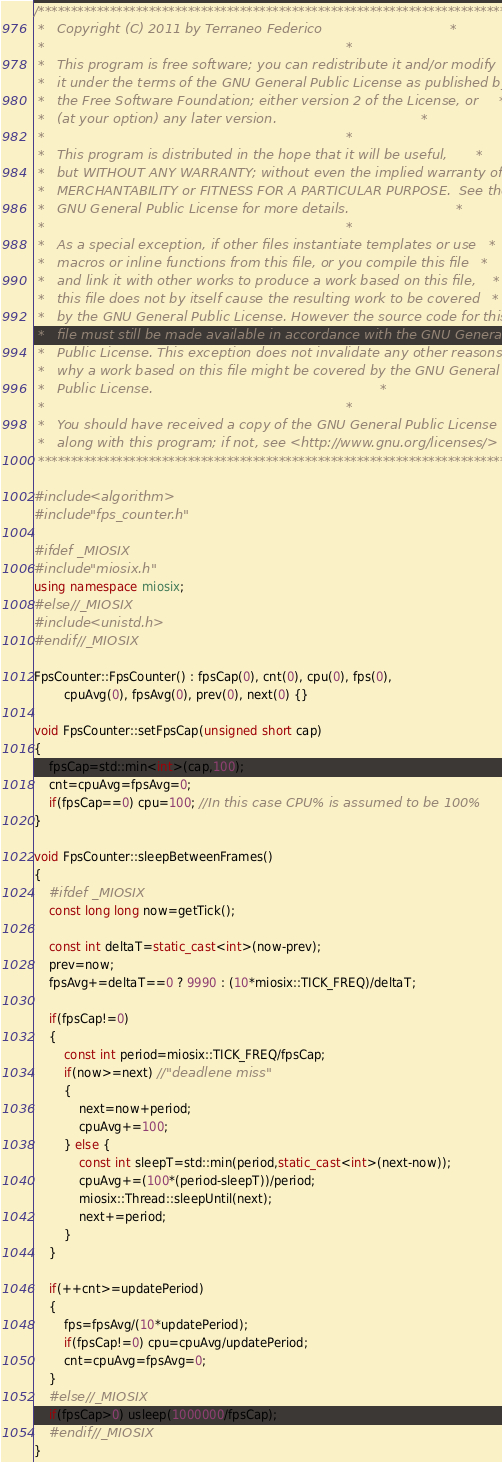<code> <loc_0><loc_0><loc_500><loc_500><_C++_>/***************************************************************************
 *   Copyright (C) 2011 by Terraneo Federico                               *
 *                                                                         *
 *   This program is free software; you can redistribute it and/or modify  *
 *   it under the terms of the GNU General Public License as published by  *
 *   the Free Software Foundation; either version 2 of the License, or     *
 *   (at your option) any later version.                                   *
 *                                                                         *
 *   This program is distributed in the hope that it will be useful,       *
 *   but WITHOUT ANY WARRANTY; without even the implied warranty of        *
 *   MERCHANTABILITY or FITNESS FOR A PARTICULAR PURPOSE.  See the         *
 *   GNU General Public License for more details.                          *
 *                                                                         *
 *   As a special exception, if other files instantiate templates or use   *
 *   macros or inline functions from this file, or you compile this file   *
 *   and link it with other works to produce a work based on this file,    *
 *   this file does not by itself cause the resulting work to be covered   *
 *   by the GNU General Public License. However the source code for this   *
 *   file must still be made available in accordance with the GNU General  *
 *   Public License. This exception does not invalidate any other reasons  *
 *   why a work based on this file might be covered by the GNU General     *
 *   Public License.                                                       *
 *                                                                         *
 *   You should have received a copy of the GNU General Public License     *
 *   along with this program; if not, see <http://www.gnu.org/licenses/>   *
 ***************************************************************************/

#include <algorithm>
#include "fps_counter.h"

#ifdef _MIOSIX
#include "miosix.h"
using namespace miosix;
#else //_MIOSIX
#include <unistd.h>
#endif //_MIOSIX

FpsCounter::FpsCounter() : fpsCap(0), cnt(0), cpu(0), fps(0),
        cpuAvg(0), fpsAvg(0), prev(0), next(0) {}

void FpsCounter::setFpsCap(unsigned short cap)
{
    fpsCap=std::min<int>(cap,100);
    cnt=cpuAvg=fpsAvg=0;
    if(fpsCap==0) cpu=100; //In this case CPU% is assumed to be 100%
}

void FpsCounter::sleepBetweenFrames()
{
    #ifdef _MIOSIX
    const long long now=getTick();

    const int deltaT=static_cast<int>(now-prev);
    prev=now;
    fpsAvg+=deltaT==0 ? 9990 : (10*miosix::TICK_FREQ)/deltaT;
    
    if(fpsCap!=0)
    {
        const int period=miosix::TICK_FREQ/fpsCap;
        if(now>=next) //"deadlene miss"
        {
            next=now+period;
            cpuAvg+=100;
        } else {
            const int sleepT=std::min(period,static_cast<int>(next-now));
            cpuAvg+=(100*(period-sleepT))/period;
            miosix::Thread::sleepUntil(next);
            next+=period;
        }
    }

    if(++cnt>=updatePeriod)
    {
        fps=fpsAvg/(10*updatePeriod);
        if(fpsCap!=0) cpu=cpuAvg/updatePeriod;
        cnt=cpuAvg=fpsAvg=0;
    }
    #else //_MIOSIX
    if(fpsCap>0) usleep(1000000/fpsCap);
    #endif //_MIOSIX
}
</code> 